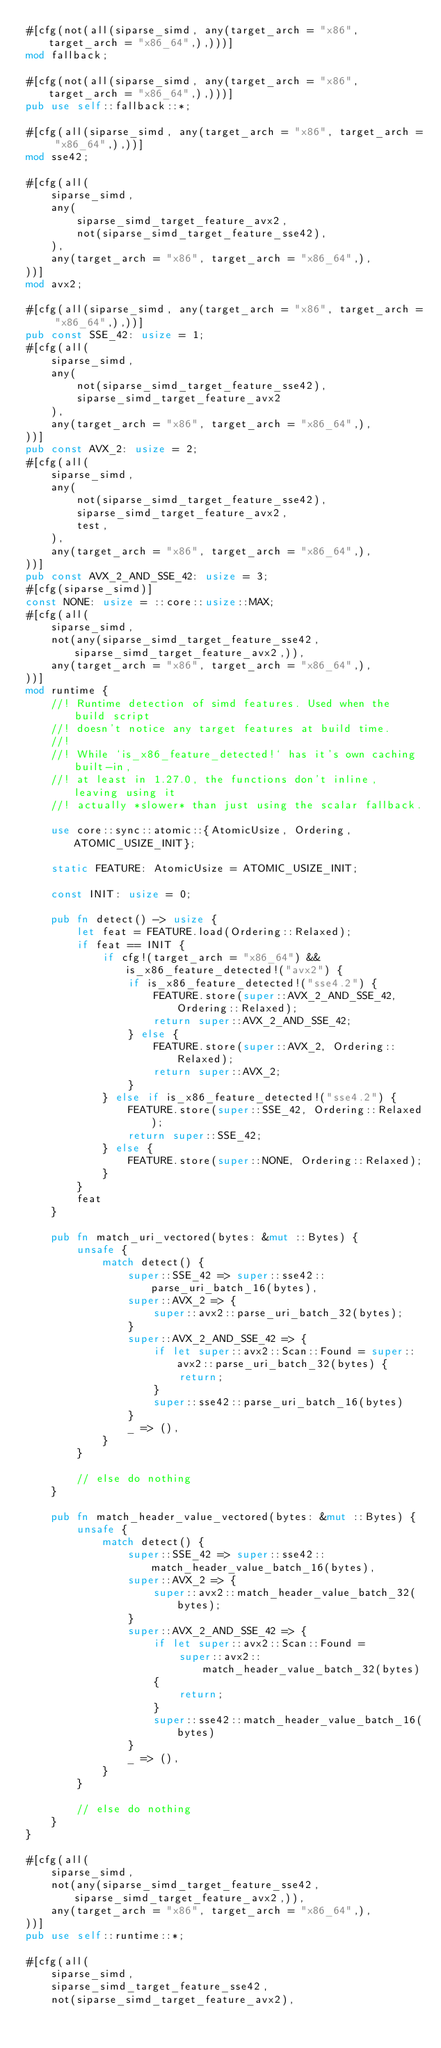Convert code to text. <code><loc_0><loc_0><loc_500><loc_500><_Rust_>#[cfg(not(all(siparse_simd, any(target_arch = "x86", target_arch = "x86_64",),)))]
mod fallback;

#[cfg(not(all(siparse_simd, any(target_arch = "x86", target_arch = "x86_64",),)))]
pub use self::fallback::*;

#[cfg(all(siparse_simd, any(target_arch = "x86", target_arch = "x86_64",),))]
mod sse42;

#[cfg(all(
    siparse_simd,
    any(
        siparse_simd_target_feature_avx2,
        not(siparse_simd_target_feature_sse42),
    ),
    any(target_arch = "x86", target_arch = "x86_64",),
))]
mod avx2;

#[cfg(all(siparse_simd, any(target_arch = "x86", target_arch = "x86_64",),))]
pub const SSE_42: usize = 1;
#[cfg(all(
    siparse_simd,
    any(
        not(siparse_simd_target_feature_sse42),
        siparse_simd_target_feature_avx2
    ),
    any(target_arch = "x86", target_arch = "x86_64",),
))]
pub const AVX_2: usize = 2;
#[cfg(all(
    siparse_simd,
    any(
        not(siparse_simd_target_feature_sse42),
        siparse_simd_target_feature_avx2,
        test,
    ),
    any(target_arch = "x86", target_arch = "x86_64",),
))]
pub const AVX_2_AND_SSE_42: usize = 3;
#[cfg(siparse_simd)]
const NONE: usize = ::core::usize::MAX;
#[cfg(all(
    siparse_simd,
    not(any(siparse_simd_target_feature_sse42, siparse_simd_target_feature_avx2,)),
    any(target_arch = "x86", target_arch = "x86_64",),
))]
mod runtime {
    //! Runtime detection of simd features. Used when the build script
    //! doesn't notice any target features at build time.
    //!
    //! While `is_x86_feature_detected!` has it's own caching built-in,
    //! at least in 1.27.0, the functions don't inline, leaving using it
    //! actually *slower* than just using the scalar fallback.

    use core::sync::atomic::{AtomicUsize, Ordering, ATOMIC_USIZE_INIT};

    static FEATURE: AtomicUsize = ATOMIC_USIZE_INIT;

    const INIT: usize = 0;

    pub fn detect() -> usize {
        let feat = FEATURE.load(Ordering::Relaxed);
        if feat == INIT {
            if cfg!(target_arch = "x86_64") && is_x86_feature_detected!("avx2") {
                if is_x86_feature_detected!("sse4.2") {
                    FEATURE.store(super::AVX_2_AND_SSE_42, Ordering::Relaxed);
                    return super::AVX_2_AND_SSE_42;
                } else {
                    FEATURE.store(super::AVX_2, Ordering::Relaxed);
                    return super::AVX_2;
                }
            } else if is_x86_feature_detected!("sse4.2") {
                FEATURE.store(super::SSE_42, Ordering::Relaxed);
                return super::SSE_42;
            } else {
                FEATURE.store(super::NONE, Ordering::Relaxed);
            }
        }
        feat
    }

    pub fn match_uri_vectored(bytes: &mut ::Bytes) {
        unsafe {
            match detect() {
                super::SSE_42 => super::sse42::parse_uri_batch_16(bytes),
                super::AVX_2 => {
                    super::avx2::parse_uri_batch_32(bytes);
                }
                super::AVX_2_AND_SSE_42 => {
                    if let super::avx2::Scan::Found = super::avx2::parse_uri_batch_32(bytes) {
                        return;
                    }
                    super::sse42::parse_uri_batch_16(bytes)
                }
                _ => (),
            }
        }

        // else do nothing
    }

    pub fn match_header_value_vectored(bytes: &mut ::Bytes) {
        unsafe {
            match detect() {
                super::SSE_42 => super::sse42::match_header_value_batch_16(bytes),
                super::AVX_2 => {
                    super::avx2::match_header_value_batch_32(bytes);
                }
                super::AVX_2_AND_SSE_42 => {
                    if let super::avx2::Scan::Found =
                        super::avx2::match_header_value_batch_32(bytes)
                    {
                        return;
                    }
                    super::sse42::match_header_value_batch_16(bytes)
                }
                _ => (),
            }
        }

        // else do nothing
    }
}

#[cfg(all(
    siparse_simd,
    not(any(siparse_simd_target_feature_sse42, siparse_simd_target_feature_avx2,)),
    any(target_arch = "x86", target_arch = "x86_64",),
))]
pub use self::runtime::*;

#[cfg(all(
    siparse_simd,
    siparse_simd_target_feature_sse42,
    not(siparse_simd_target_feature_avx2),</code> 